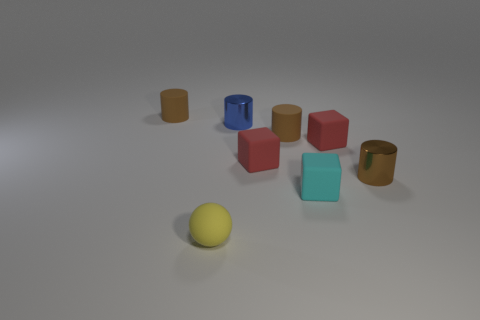Subtract all tiny red cubes. How many cubes are left? 1 Subtract all brown spheres. How many red cubes are left? 2 Subtract all blue cylinders. How many cylinders are left? 3 Subtract 1 cylinders. How many cylinders are left? 3 Add 1 red things. How many objects exist? 9 Subtract all purple cylinders. Subtract all purple blocks. How many cylinders are left? 4 Add 7 cyan rubber cubes. How many cyan rubber cubes are left? 8 Add 4 cyan things. How many cyan things exist? 5 Subtract 2 brown cylinders. How many objects are left? 6 Subtract all balls. How many objects are left? 7 